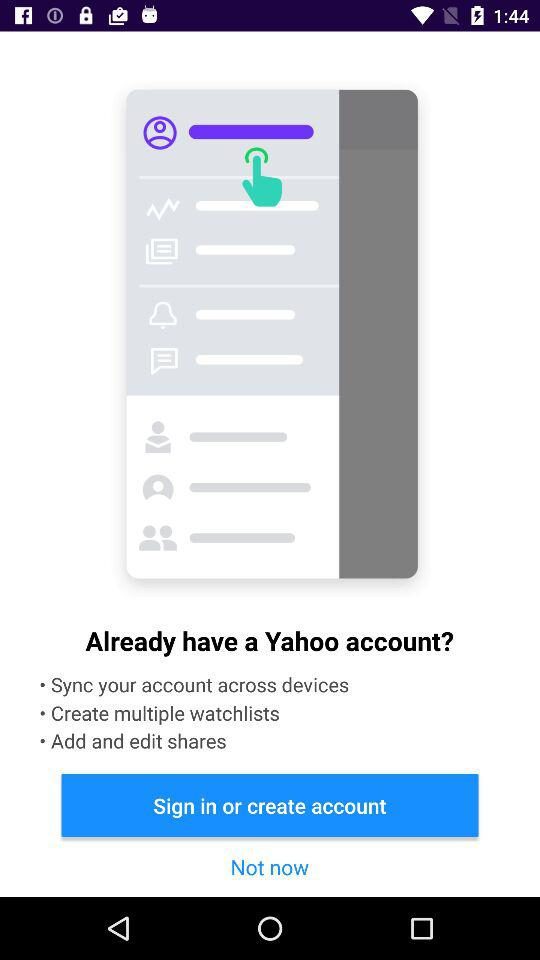What is the application name?
When the provided information is insufficient, respond with <no answer>. <no answer> 